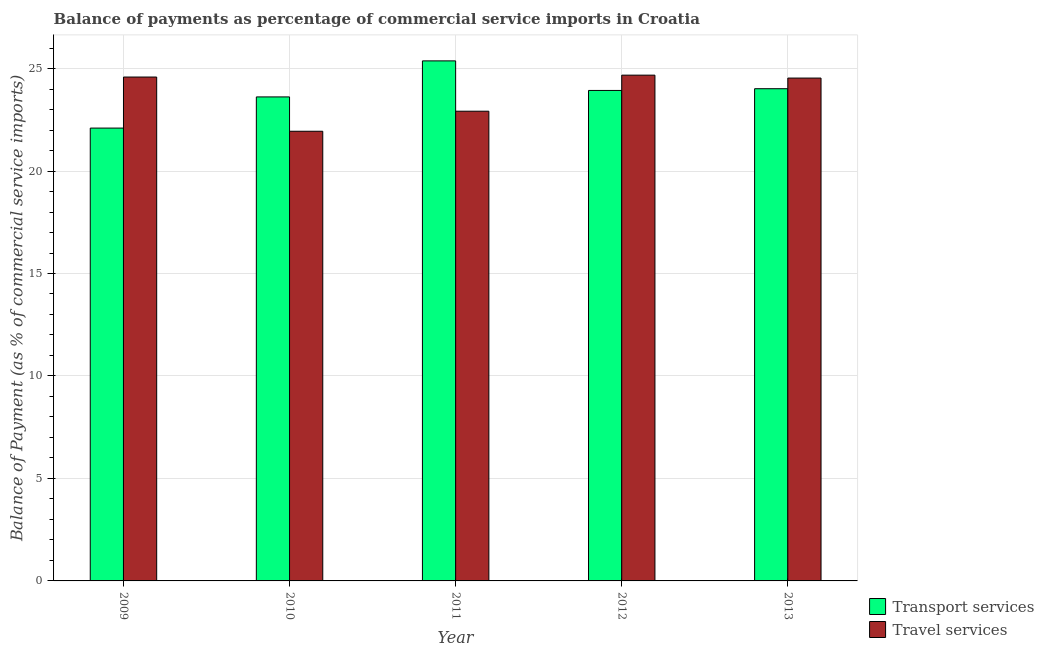How many different coloured bars are there?
Your response must be concise. 2. Are the number of bars per tick equal to the number of legend labels?
Your response must be concise. Yes. Are the number of bars on each tick of the X-axis equal?
Your answer should be very brief. Yes. How many bars are there on the 4th tick from the left?
Your answer should be compact. 2. How many bars are there on the 5th tick from the right?
Offer a very short reply. 2. What is the balance of payments of travel services in 2011?
Offer a very short reply. 22.92. Across all years, what is the maximum balance of payments of travel services?
Ensure brevity in your answer.  24.68. Across all years, what is the minimum balance of payments of travel services?
Your response must be concise. 21.94. In which year was the balance of payments of transport services minimum?
Keep it short and to the point. 2009. What is the total balance of payments of transport services in the graph?
Give a very brief answer. 119.03. What is the difference between the balance of payments of travel services in 2009 and that in 2013?
Offer a terse response. 0.05. What is the difference between the balance of payments of transport services in 2013 and the balance of payments of travel services in 2010?
Your response must be concise. 0.4. What is the average balance of payments of travel services per year?
Your answer should be very brief. 23.73. What is the ratio of the balance of payments of transport services in 2012 to that in 2013?
Provide a succinct answer. 1. Is the balance of payments of travel services in 2009 less than that in 2010?
Keep it short and to the point. No. What is the difference between the highest and the second highest balance of payments of transport services?
Make the answer very short. 1.36. What is the difference between the highest and the lowest balance of payments of travel services?
Give a very brief answer. 2.74. In how many years, is the balance of payments of travel services greater than the average balance of payments of travel services taken over all years?
Ensure brevity in your answer.  3. Is the sum of the balance of payments of travel services in 2011 and 2012 greater than the maximum balance of payments of transport services across all years?
Your answer should be very brief. Yes. What does the 2nd bar from the left in 2013 represents?
Keep it short and to the point. Travel services. What does the 1st bar from the right in 2013 represents?
Offer a very short reply. Travel services. What is the difference between two consecutive major ticks on the Y-axis?
Your response must be concise. 5. Does the graph contain any zero values?
Make the answer very short. No. Does the graph contain grids?
Your answer should be compact. Yes. What is the title of the graph?
Ensure brevity in your answer.  Balance of payments as percentage of commercial service imports in Croatia. What is the label or title of the X-axis?
Provide a short and direct response. Year. What is the label or title of the Y-axis?
Your response must be concise. Balance of Payment (as % of commercial service imports). What is the Balance of Payment (as % of commercial service imports) of Transport services in 2009?
Ensure brevity in your answer.  22.1. What is the Balance of Payment (as % of commercial service imports) in Travel services in 2009?
Provide a succinct answer. 24.59. What is the Balance of Payment (as % of commercial service imports) in Transport services in 2010?
Your response must be concise. 23.62. What is the Balance of Payment (as % of commercial service imports) of Travel services in 2010?
Give a very brief answer. 21.94. What is the Balance of Payment (as % of commercial service imports) in Transport services in 2011?
Make the answer very short. 25.37. What is the Balance of Payment (as % of commercial service imports) of Travel services in 2011?
Provide a short and direct response. 22.92. What is the Balance of Payment (as % of commercial service imports) in Transport services in 2012?
Give a very brief answer. 23.93. What is the Balance of Payment (as % of commercial service imports) of Travel services in 2012?
Give a very brief answer. 24.68. What is the Balance of Payment (as % of commercial service imports) in Transport services in 2013?
Offer a terse response. 24.02. What is the Balance of Payment (as % of commercial service imports) in Travel services in 2013?
Offer a terse response. 24.54. Across all years, what is the maximum Balance of Payment (as % of commercial service imports) of Transport services?
Your answer should be compact. 25.37. Across all years, what is the maximum Balance of Payment (as % of commercial service imports) of Travel services?
Provide a succinct answer. 24.68. Across all years, what is the minimum Balance of Payment (as % of commercial service imports) of Transport services?
Offer a very short reply. 22.1. Across all years, what is the minimum Balance of Payment (as % of commercial service imports) of Travel services?
Your answer should be very brief. 21.94. What is the total Balance of Payment (as % of commercial service imports) in Transport services in the graph?
Your response must be concise. 119.03. What is the total Balance of Payment (as % of commercial service imports) in Travel services in the graph?
Provide a succinct answer. 118.66. What is the difference between the Balance of Payment (as % of commercial service imports) of Transport services in 2009 and that in 2010?
Give a very brief answer. -1.52. What is the difference between the Balance of Payment (as % of commercial service imports) in Travel services in 2009 and that in 2010?
Keep it short and to the point. 2.65. What is the difference between the Balance of Payment (as % of commercial service imports) of Transport services in 2009 and that in 2011?
Make the answer very short. -3.28. What is the difference between the Balance of Payment (as % of commercial service imports) of Travel services in 2009 and that in 2011?
Your response must be concise. 1.67. What is the difference between the Balance of Payment (as % of commercial service imports) of Transport services in 2009 and that in 2012?
Ensure brevity in your answer.  -1.84. What is the difference between the Balance of Payment (as % of commercial service imports) in Travel services in 2009 and that in 2012?
Your answer should be compact. -0.09. What is the difference between the Balance of Payment (as % of commercial service imports) of Transport services in 2009 and that in 2013?
Provide a short and direct response. -1.92. What is the difference between the Balance of Payment (as % of commercial service imports) of Travel services in 2009 and that in 2013?
Provide a short and direct response. 0.05. What is the difference between the Balance of Payment (as % of commercial service imports) in Transport services in 2010 and that in 2011?
Keep it short and to the point. -1.76. What is the difference between the Balance of Payment (as % of commercial service imports) of Travel services in 2010 and that in 2011?
Make the answer very short. -0.98. What is the difference between the Balance of Payment (as % of commercial service imports) of Transport services in 2010 and that in 2012?
Your answer should be very brief. -0.32. What is the difference between the Balance of Payment (as % of commercial service imports) of Travel services in 2010 and that in 2012?
Ensure brevity in your answer.  -2.74. What is the difference between the Balance of Payment (as % of commercial service imports) in Transport services in 2010 and that in 2013?
Ensure brevity in your answer.  -0.4. What is the difference between the Balance of Payment (as % of commercial service imports) of Travel services in 2010 and that in 2013?
Your answer should be compact. -2.59. What is the difference between the Balance of Payment (as % of commercial service imports) in Transport services in 2011 and that in 2012?
Your response must be concise. 1.44. What is the difference between the Balance of Payment (as % of commercial service imports) in Travel services in 2011 and that in 2012?
Give a very brief answer. -1.76. What is the difference between the Balance of Payment (as % of commercial service imports) in Transport services in 2011 and that in 2013?
Make the answer very short. 1.36. What is the difference between the Balance of Payment (as % of commercial service imports) in Travel services in 2011 and that in 2013?
Your answer should be very brief. -1.62. What is the difference between the Balance of Payment (as % of commercial service imports) of Transport services in 2012 and that in 2013?
Make the answer very short. -0.08. What is the difference between the Balance of Payment (as % of commercial service imports) of Travel services in 2012 and that in 2013?
Ensure brevity in your answer.  0.14. What is the difference between the Balance of Payment (as % of commercial service imports) in Transport services in 2009 and the Balance of Payment (as % of commercial service imports) in Travel services in 2010?
Ensure brevity in your answer.  0.15. What is the difference between the Balance of Payment (as % of commercial service imports) in Transport services in 2009 and the Balance of Payment (as % of commercial service imports) in Travel services in 2011?
Make the answer very short. -0.82. What is the difference between the Balance of Payment (as % of commercial service imports) in Transport services in 2009 and the Balance of Payment (as % of commercial service imports) in Travel services in 2012?
Your answer should be compact. -2.58. What is the difference between the Balance of Payment (as % of commercial service imports) of Transport services in 2009 and the Balance of Payment (as % of commercial service imports) of Travel services in 2013?
Make the answer very short. -2.44. What is the difference between the Balance of Payment (as % of commercial service imports) in Transport services in 2010 and the Balance of Payment (as % of commercial service imports) in Travel services in 2011?
Keep it short and to the point. 0.7. What is the difference between the Balance of Payment (as % of commercial service imports) of Transport services in 2010 and the Balance of Payment (as % of commercial service imports) of Travel services in 2012?
Your response must be concise. -1.06. What is the difference between the Balance of Payment (as % of commercial service imports) in Transport services in 2010 and the Balance of Payment (as % of commercial service imports) in Travel services in 2013?
Make the answer very short. -0.92. What is the difference between the Balance of Payment (as % of commercial service imports) in Transport services in 2011 and the Balance of Payment (as % of commercial service imports) in Travel services in 2012?
Give a very brief answer. 0.7. What is the difference between the Balance of Payment (as % of commercial service imports) in Transport services in 2011 and the Balance of Payment (as % of commercial service imports) in Travel services in 2013?
Offer a very short reply. 0.84. What is the difference between the Balance of Payment (as % of commercial service imports) of Transport services in 2012 and the Balance of Payment (as % of commercial service imports) of Travel services in 2013?
Offer a very short reply. -0.6. What is the average Balance of Payment (as % of commercial service imports) of Transport services per year?
Provide a short and direct response. 23.81. What is the average Balance of Payment (as % of commercial service imports) of Travel services per year?
Your answer should be very brief. 23.73. In the year 2009, what is the difference between the Balance of Payment (as % of commercial service imports) of Transport services and Balance of Payment (as % of commercial service imports) of Travel services?
Provide a succinct answer. -2.49. In the year 2010, what is the difference between the Balance of Payment (as % of commercial service imports) in Transport services and Balance of Payment (as % of commercial service imports) in Travel services?
Keep it short and to the point. 1.68. In the year 2011, what is the difference between the Balance of Payment (as % of commercial service imports) of Transport services and Balance of Payment (as % of commercial service imports) of Travel services?
Your answer should be compact. 2.46. In the year 2012, what is the difference between the Balance of Payment (as % of commercial service imports) of Transport services and Balance of Payment (as % of commercial service imports) of Travel services?
Offer a very short reply. -0.75. In the year 2013, what is the difference between the Balance of Payment (as % of commercial service imports) of Transport services and Balance of Payment (as % of commercial service imports) of Travel services?
Your answer should be very brief. -0.52. What is the ratio of the Balance of Payment (as % of commercial service imports) in Transport services in 2009 to that in 2010?
Make the answer very short. 0.94. What is the ratio of the Balance of Payment (as % of commercial service imports) in Travel services in 2009 to that in 2010?
Offer a very short reply. 1.12. What is the ratio of the Balance of Payment (as % of commercial service imports) in Transport services in 2009 to that in 2011?
Offer a terse response. 0.87. What is the ratio of the Balance of Payment (as % of commercial service imports) in Travel services in 2009 to that in 2011?
Offer a very short reply. 1.07. What is the ratio of the Balance of Payment (as % of commercial service imports) in Transport services in 2009 to that in 2012?
Offer a terse response. 0.92. What is the ratio of the Balance of Payment (as % of commercial service imports) in Transport services in 2009 to that in 2013?
Your answer should be compact. 0.92. What is the ratio of the Balance of Payment (as % of commercial service imports) in Travel services in 2009 to that in 2013?
Give a very brief answer. 1. What is the ratio of the Balance of Payment (as % of commercial service imports) of Transport services in 2010 to that in 2011?
Give a very brief answer. 0.93. What is the ratio of the Balance of Payment (as % of commercial service imports) of Travel services in 2010 to that in 2011?
Ensure brevity in your answer.  0.96. What is the ratio of the Balance of Payment (as % of commercial service imports) in Travel services in 2010 to that in 2012?
Your answer should be very brief. 0.89. What is the ratio of the Balance of Payment (as % of commercial service imports) in Transport services in 2010 to that in 2013?
Offer a very short reply. 0.98. What is the ratio of the Balance of Payment (as % of commercial service imports) in Travel services in 2010 to that in 2013?
Offer a terse response. 0.89. What is the ratio of the Balance of Payment (as % of commercial service imports) in Transport services in 2011 to that in 2012?
Provide a short and direct response. 1.06. What is the ratio of the Balance of Payment (as % of commercial service imports) of Travel services in 2011 to that in 2012?
Make the answer very short. 0.93. What is the ratio of the Balance of Payment (as % of commercial service imports) of Transport services in 2011 to that in 2013?
Your answer should be very brief. 1.06. What is the ratio of the Balance of Payment (as % of commercial service imports) of Travel services in 2011 to that in 2013?
Give a very brief answer. 0.93. What is the ratio of the Balance of Payment (as % of commercial service imports) in Transport services in 2012 to that in 2013?
Provide a short and direct response. 1. What is the difference between the highest and the second highest Balance of Payment (as % of commercial service imports) in Transport services?
Offer a very short reply. 1.36. What is the difference between the highest and the second highest Balance of Payment (as % of commercial service imports) in Travel services?
Offer a terse response. 0.09. What is the difference between the highest and the lowest Balance of Payment (as % of commercial service imports) of Transport services?
Your answer should be compact. 3.28. What is the difference between the highest and the lowest Balance of Payment (as % of commercial service imports) of Travel services?
Keep it short and to the point. 2.74. 